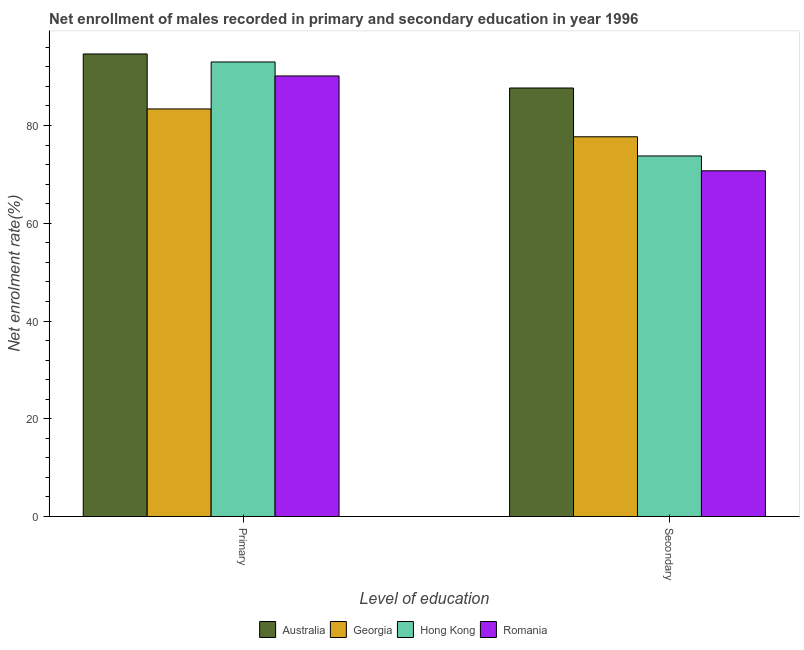How many groups of bars are there?
Make the answer very short. 2. What is the label of the 1st group of bars from the left?
Give a very brief answer. Primary. What is the enrollment rate in primary education in Georgia?
Offer a very short reply. 83.38. Across all countries, what is the maximum enrollment rate in primary education?
Ensure brevity in your answer.  94.64. Across all countries, what is the minimum enrollment rate in secondary education?
Your answer should be very brief. 70.73. In which country was the enrollment rate in primary education maximum?
Your answer should be very brief. Australia. In which country was the enrollment rate in primary education minimum?
Your response must be concise. Georgia. What is the total enrollment rate in secondary education in the graph?
Your answer should be very brief. 309.86. What is the difference between the enrollment rate in primary education in Romania and that in Georgia?
Give a very brief answer. 6.75. What is the difference between the enrollment rate in secondary education in Hong Kong and the enrollment rate in primary education in Romania?
Provide a short and direct response. -16.37. What is the average enrollment rate in secondary education per country?
Offer a very short reply. 77.47. What is the difference between the enrollment rate in secondary education and enrollment rate in primary education in Hong Kong?
Ensure brevity in your answer.  -19.23. What is the ratio of the enrollment rate in secondary education in Australia to that in Hong Kong?
Offer a terse response. 1.19. What does the 3rd bar from the left in Primary represents?
Offer a terse response. Hong Kong. What does the 2nd bar from the right in Secondary represents?
Your answer should be compact. Hong Kong. How many bars are there?
Your answer should be very brief. 8. Are all the bars in the graph horizontal?
Keep it short and to the point. No. What is the difference between two consecutive major ticks on the Y-axis?
Keep it short and to the point. 20. Are the values on the major ticks of Y-axis written in scientific E-notation?
Offer a very short reply. No. Does the graph contain any zero values?
Provide a succinct answer. No. How many legend labels are there?
Your answer should be very brief. 4. How are the legend labels stacked?
Provide a short and direct response. Horizontal. What is the title of the graph?
Keep it short and to the point. Net enrollment of males recorded in primary and secondary education in year 1996. Does "Morocco" appear as one of the legend labels in the graph?
Make the answer very short. No. What is the label or title of the X-axis?
Ensure brevity in your answer.  Level of education. What is the label or title of the Y-axis?
Keep it short and to the point. Net enrolment rate(%). What is the Net enrolment rate(%) of Australia in Primary?
Give a very brief answer. 94.64. What is the Net enrolment rate(%) of Georgia in Primary?
Provide a short and direct response. 83.38. What is the Net enrolment rate(%) of Hong Kong in Primary?
Ensure brevity in your answer.  92.99. What is the Net enrolment rate(%) in Romania in Primary?
Your answer should be compact. 90.14. What is the Net enrolment rate(%) in Australia in Secondary?
Provide a short and direct response. 87.67. What is the Net enrolment rate(%) in Georgia in Secondary?
Your answer should be very brief. 77.69. What is the Net enrolment rate(%) of Hong Kong in Secondary?
Keep it short and to the point. 73.77. What is the Net enrolment rate(%) in Romania in Secondary?
Your response must be concise. 70.73. Across all Level of education, what is the maximum Net enrolment rate(%) in Australia?
Your response must be concise. 94.64. Across all Level of education, what is the maximum Net enrolment rate(%) of Georgia?
Your answer should be compact. 83.38. Across all Level of education, what is the maximum Net enrolment rate(%) in Hong Kong?
Give a very brief answer. 92.99. Across all Level of education, what is the maximum Net enrolment rate(%) of Romania?
Provide a succinct answer. 90.14. Across all Level of education, what is the minimum Net enrolment rate(%) of Australia?
Offer a terse response. 87.67. Across all Level of education, what is the minimum Net enrolment rate(%) of Georgia?
Keep it short and to the point. 77.69. Across all Level of education, what is the minimum Net enrolment rate(%) of Hong Kong?
Ensure brevity in your answer.  73.77. Across all Level of education, what is the minimum Net enrolment rate(%) of Romania?
Provide a short and direct response. 70.73. What is the total Net enrolment rate(%) in Australia in the graph?
Ensure brevity in your answer.  182.31. What is the total Net enrolment rate(%) in Georgia in the graph?
Provide a succinct answer. 161.08. What is the total Net enrolment rate(%) in Hong Kong in the graph?
Provide a short and direct response. 166.76. What is the total Net enrolment rate(%) in Romania in the graph?
Provide a succinct answer. 160.87. What is the difference between the Net enrolment rate(%) of Australia in Primary and that in Secondary?
Ensure brevity in your answer.  6.97. What is the difference between the Net enrolment rate(%) of Georgia in Primary and that in Secondary?
Ensure brevity in your answer.  5.69. What is the difference between the Net enrolment rate(%) in Hong Kong in Primary and that in Secondary?
Make the answer very short. 19.23. What is the difference between the Net enrolment rate(%) of Romania in Primary and that in Secondary?
Offer a terse response. 19.4. What is the difference between the Net enrolment rate(%) in Australia in Primary and the Net enrolment rate(%) in Georgia in Secondary?
Keep it short and to the point. 16.94. What is the difference between the Net enrolment rate(%) in Australia in Primary and the Net enrolment rate(%) in Hong Kong in Secondary?
Offer a terse response. 20.87. What is the difference between the Net enrolment rate(%) of Australia in Primary and the Net enrolment rate(%) of Romania in Secondary?
Provide a short and direct response. 23.9. What is the difference between the Net enrolment rate(%) of Georgia in Primary and the Net enrolment rate(%) of Hong Kong in Secondary?
Provide a succinct answer. 9.62. What is the difference between the Net enrolment rate(%) of Georgia in Primary and the Net enrolment rate(%) of Romania in Secondary?
Ensure brevity in your answer.  12.65. What is the difference between the Net enrolment rate(%) of Hong Kong in Primary and the Net enrolment rate(%) of Romania in Secondary?
Provide a succinct answer. 22.26. What is the average Net enrolment rate(%) of Australia per Level of education?
Give a very brief answer. 91.15. What is the average Net enrolment rate(%) of Georgia per Level of education?
Ensure brevity in your answer.  80.54. What is the average Net enrolment rate(%) of Hong Kong per Level of education?
Offer a very short reply. 83.38. What is the average Net enrolment rate(%) of Romania per Level of education?
Provide a short and direct response. 80.44. What is the difference between the Net enrolment rate(%) of Australia and Net enrolment rate(%) of Georgia in Primary?
Your answer should be very brief. 11.25. What is the difference between the Net enrolment rate(%) of Australia and Net enrolment rate(%) of Hong Kong in Primary?
Provide a short and direct response. 1.64. What is the difference between the Net enrolment rate(%) in Australia and Net enrolment rate(%) in Romania in Primary?
Your answer should be very brief. 4.5. What is the difference between the Net enrolment rate(%) of Georgia and Net enrolment rate(%) of Hong Kong in Primary?
Make the answer very short. -9.61. What is the difference between the Net enrolment rate(%) in Georgia and Net enrolment rate(%) in Romania in Primary?
Ensure brevity in your answer.  -6.75. What is the difference between the Net enrolment rate(%) in Hong Kong and Net enrolment rate(%) in Romania in Primary?
Keep it short and to the point. 2.86. What is the difference between the Net enrolment rate(%) in Australia and Net enrolment rate(%) in Georgia in Secondary?
Ensure brevity in your answer.  9.98. What is the difference between the Net enrolment rate(%) in Australia and Net enrolment rate(%) in Hong Kong in Secondary?
Provide a succinct answer. 13.9. What is the difference between the Net enrolment rate(%) in Australia and Net enrolment rate(%) in Romania in Secondary?
Provide a short and direct response. 16.94. What is the difference between the Net enrolment rate(%) in Georgia and Net enrolment rate(%) in Hong Kong in Secondary?
Your answer should be very brief. 3.93. What is the difference between the Net enrolment rate(%) of Georgia and Net enrolment rate(%) of Romania in Secondary?
Provide a short and direct response. 6.96. What is the difference between the Net enrolment rate(%) in Hong Kong and Net enrolment rate(%) in Romania in Secondary?
Ensure brevity in your answer.  3.03. What is the ratio of the Net enrolment rate(%) in Australia in Primary to that in Secondary?
Keep it short and to the point. 1.08. What is the ratio of the Net enrolment rate(%) in Georgia in Primary to that in Secondary?
Offer a very short reply. 1.07. What is the ratio of the Net enrolment rate(%) of Hong Kong in Primary to that in Secondary?
Give a very brief answer. 1.26. What is the ratio of the Net enrolment rate(%) of Romania in Primary to that in Secondary?
Give a very brief answer. 1.27. What is the difference between the highest and the second highest Net enrolment rate(%) in Australia?
Offer a very short reply. 6.97. What is the difference between the highest and the second highest Net enrolment rate(%) in Georgia?
Your answer should be compact. 5.69. What is the difference between the highest and the second highest Net enrolment rate(%) in Hong Kong?
Provide a succinct answer. 19.23. What is the difference between the highest and the second highest Net enrolment rate(%) in Romania?
Your response must be concise. 19.4. What is the difference between the highest and the lowest Net enrolment rate(%) in Australia?
Offer a terse response. 6.97. What is the difference between the highest and the lowest Net enrolment rate(%) in Georgia?
Your answer should be compact. 5.69. What is the difference between the highest and the lowest Net enrolment rate(%) of Hong Kong?
Provide a succinct answer. 19.23. What is the difference between the highest and the lowest Net enrolment rate(%) of Romania?
Give a very brief answer. 19.4. 